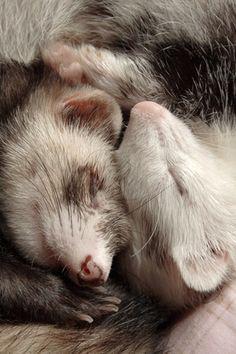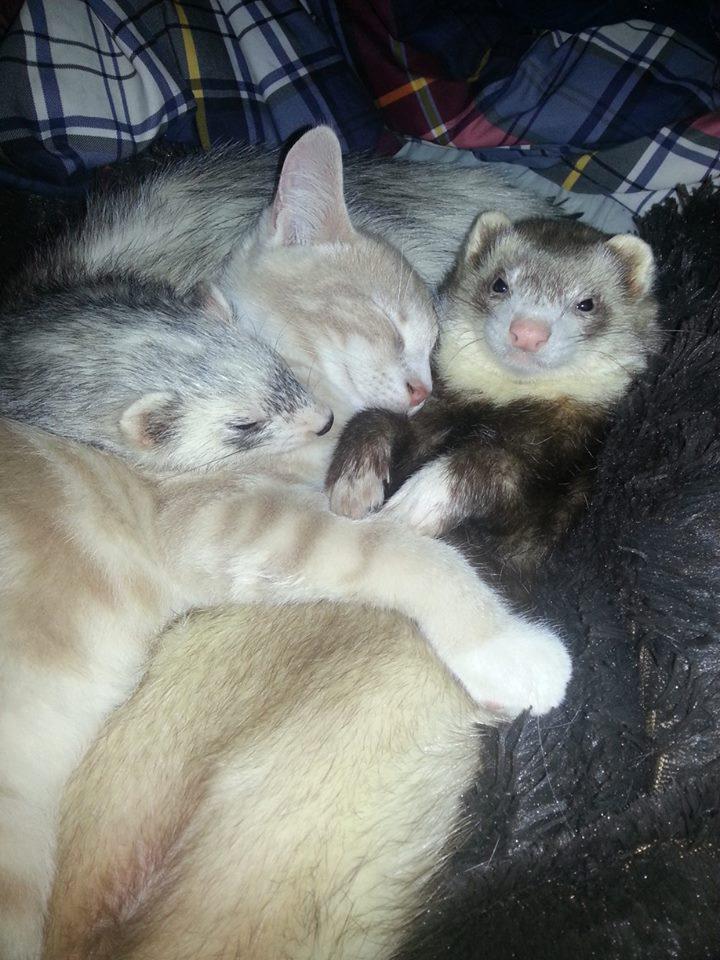The first image is the image on the left, the second image is the image on the right. For the images shown, is this caption "One image shows two ferrets sleeping with a cat in between them, and the other shows exactly two animal faces side-by-side." true? Answer yes or no. Yes. The first image is the image on the left, the second image is the image on the right. Evaluate the accuracy of this statement regarding the images: "There is more than one animal species in the image.". Is it true? Answer yes or no. Yes. 